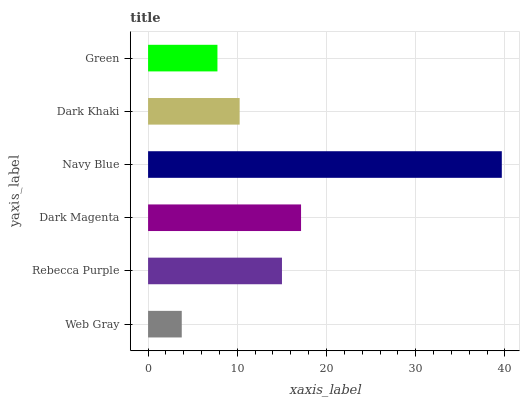Is Web Gray the minimum?
Answer yes or no. Yes. Is Navy Blue the maximum?
Answer yes or no. Yes. Is Rebecca Purple the minimum?
Answer yes or no. No. Is Rebecca Purple the maximum?
Answer yes or no. No. Is Rebecca Purple greater than Web Gray?
Answer yes or no. Yes. Is Web Gray less than Rebecca Purple?
Answer yes or no. Yes. Is Web Gray greater than Rebecca Purple?
Answer yes or no. No. Is Rebecca Purple less than Web Gray?
Answer yes or no. No. Is Rebecca Purple the high median?
Answer yes or no. Yes. Is Dark Khaki the low median?
Answer yes or no. Yes. Is Green the high median?
Answer yes or no. No. Is Rebecca Purple the low median?
Answer yes or no. No. 